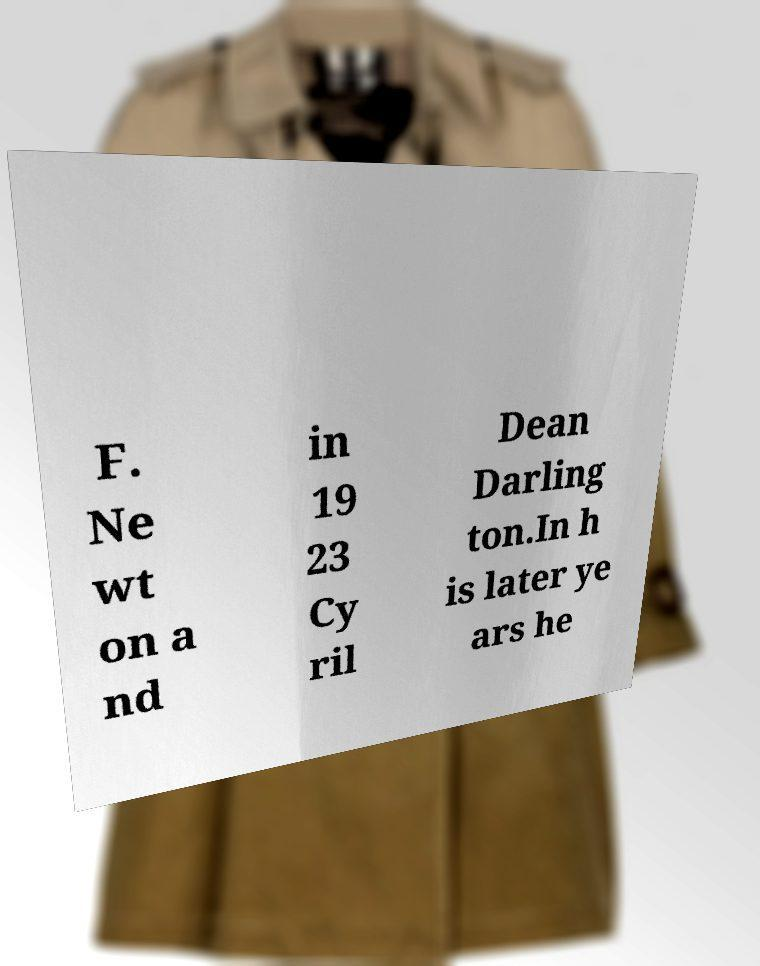Could you assist in decoding the text presented in this image and type it out clearly? F. Ne wt on a nd in 19 23 Cy ril Dean Darling ton.In h is later ye ars he 